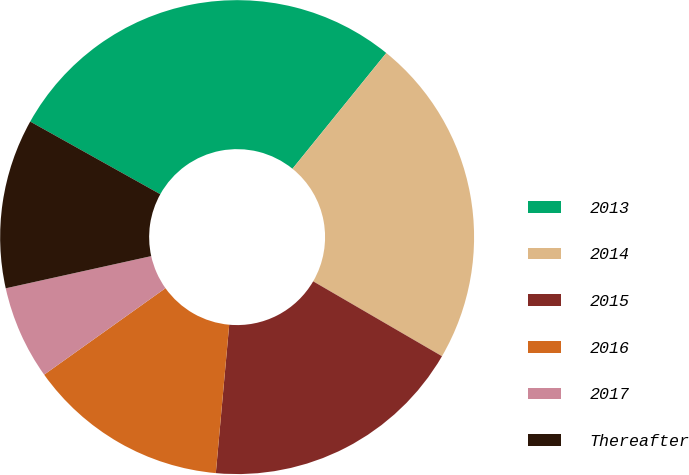<chart> <loc_0><loc_0><loc_500><loc_500><pie_chart><fcel>2013<fcel>2014<fcel>2015<fcel>2016<fcel>2017<fcel>Thereafter<nl><fcel>27.73%<fcel>22.54%<fcel>18.05%<fcel>13.71%<fcel>6.39%<fcel>11.57%<nl></chart> 